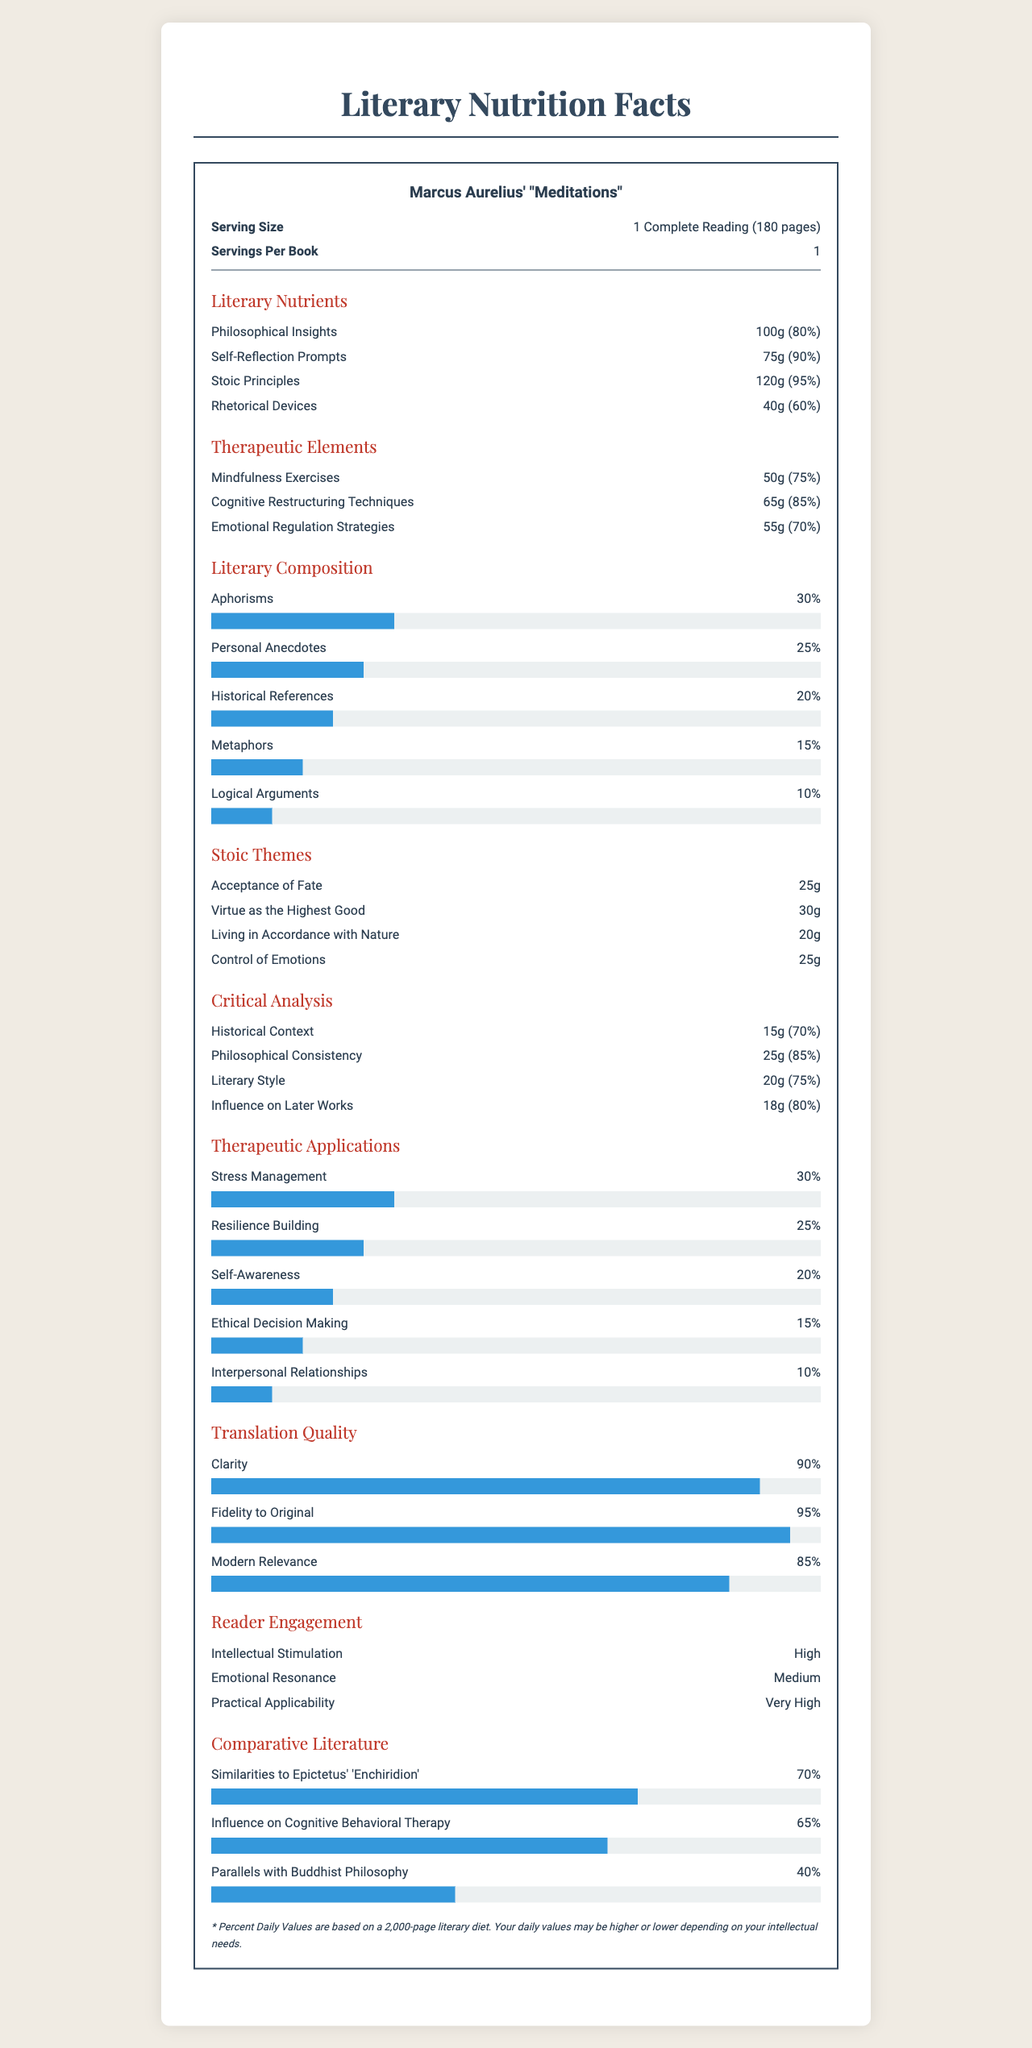what is the serving size? Based on the document, the serving size is listed as "1 Complete Reading (180 pages)".
Answer: 1 Complete Reading (180 pages) how much is the daily value of Philosophical Insights? The document lists the daily value of Philosophical Insights as 80%.
Answer: 80% list two elements under Therapeutic Elements and their daily values. The document states that the daily value for Mindfulness Exercises is 75% and for Cognitive Restructuring Techniques is 85%.
Answer: Mindfulness Exercises (75%) and Cognitive Restructuring Techniques (85%) which literary composition has the highest percentage in Meditations? According to the document, Aphorisms make up 30% of the literary composition, which is the highest percentage.
Answer: Aphorisms (30%) what is the percentage of Self-Reflection Prompts in the document? The daily value of Self-Reflection Prompts is listed as 90%, with an amount of 75g.
Answer: 75g, 90% based on the document, what is the serving size of Marcus Aurelius’ "Meditations"? A. 1 Chapter (10 pages) B. 1 Complete Reading (180 pages) C. 1 Page The document states that the serving size is 1 Complete Reading (180 pages).
Answer: B what percentage of the document is dedicated to Emotional Regulation Strategies? A. 70% B. 75% C. 85% The document specifies that Emotional Regulation Strategies have a daily value of 70%.
Answer: A is the historical context for understanding "Meditations" well covered in the document? The document indicates that the Historical Context part amounts to 15g, with a daily value of 70%.
Answer: Yes Summarize the key themes and components discussed in the document. The document provides a detailed breakdown of the contents and benefits of "Meditations," presenting it as both a literary and therapeutic resource, with specific emphasis on its Stoic themes and psychological applications.
Answer: The document outlines the literary and therapeutic aspects of Marcus Aurelius' "Meditations." It covers the composition of philosophical insights, self-reflection prompts, and Stoic principles, while also emphasizing therapeutic elements such as mindfulness exercises and cognitive restructuring techniques. Moreover, the document evaluates critical analysis elements, translation quality, reader engagement, and comparative literature aspects. What was Marcus Aurelius' favorite Stoic principle based on this document? The document does not provide information on Marcus Aurelius' personal preferences regarding Stoic principles.
Answer: Cannot be determined what is the daily value of Stoic Principles in the document? The daily value of Stoic Principles is indicated as 95% in the document.
Answer: 95% What percentage of the document is devoted to Metaphors? The document lists Metaphors as comprising 15% of the literary composition.
Answer: 15% Which of the following aspects has the lowest daily value in the Critical Analysis section? I. Historical Context II. Philosophical Consistency III. Influence on Later Works Historical Context has the lowest daily value at 70% in the Critical Analysis section.
Answer: I. Historical Context does Marcus Aurelius’ "Meditations" have high practical applicability for readers? The document states that the practical applicability for readers is rated as "Very High."
Answer: Yes Compare the influence of "Meditations" on Cognitive Behavioral Therapy and Buddhist Philosophy. Which has a higher similarity percentage? The document lists Cognitive Behavioral Therapy similarity at 65% and Buddhist Philosophy at 40%, indicating a higher similarity with Cognitive Behavioral Therapy.
Answer: Influence on Cognitive Behavioral Therapy (65%) 